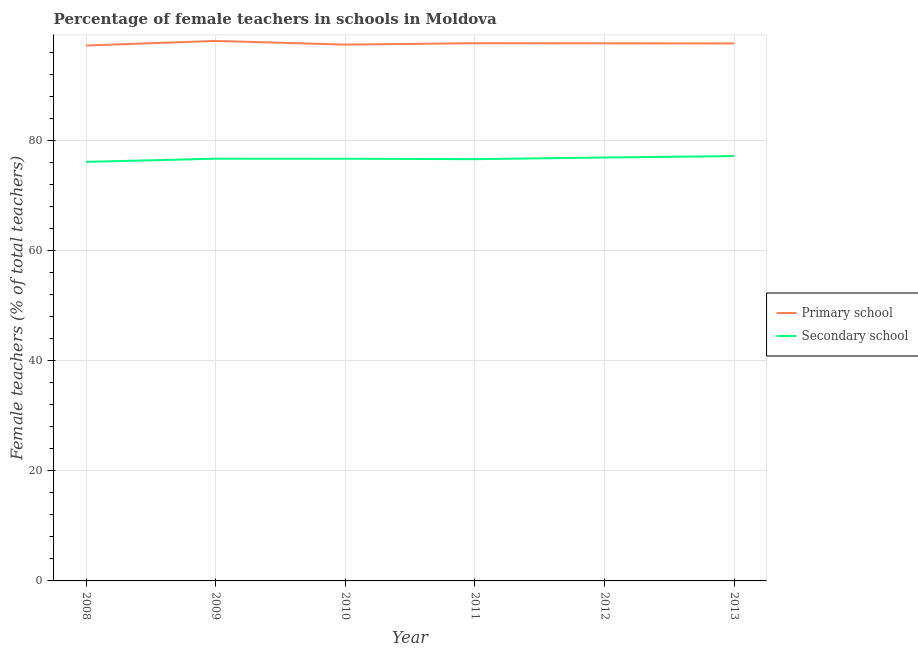How many different coloured lines are there?
Offer a very short reply. 2. Is the number of lines equal to the number of legend labels?
Ensure brevity in your answer.  Yes. What is the percentage of female teachers in secondary schools in 2012?
Give a very brief answer. 76.97. Across all years, what is the maximum percentage of female teachers in primary schools?
Keep it short and to the point. 98.16. Across all years, what is the minimum percentage of female teachers in primary schools?
Your answer should be very brief. 97.32. In which year was the percentage of female teachers in primary schools maximum?
Provide a succinct answer. 2009. In which year was the percentage of female teachers in secondary schools minimum?
Keep it short and to the point. 2008. What is the total percentage of female teachers in primary schools in the graph?
Offer a terse response. 586.14. What is the difference between the percentage of female teachers in secondary schools in 2009 and that in 2010?
Provide a short and direct response. 0.01. What is the difference between the percentage of female teachers in secondary schools in 2013 and the percentage of female teachers in primary schools in 2011?
Your answer should be compact. -20.52. What is the average percentage of female teachers in secondary schools per year?
Give a very brief answer. 76.75. In the year 2009, what is the difference between the percentage of female teachers in primary schools and percentage of female teachers in secondary schools?
Your answer should be compact. 21.41. In how many years, is the percentage of female teachers in primary schools greater than 68 %?
Give a very brief answer. 6. What is the ratio of the percentage of female teachers in secondary schools in 2010 to that in 2012?
Ensure brevity in your answer.  1. Is the percentage of female teachers in secondary schools in 2010 less than that in 2012?
Provide a short and direct response. Yes. Is the difference between the percentage of female teachers in primary schools in 2010 and 2011 greater than the difference between the percentage of female teachers in secondary schools in 2010 and 2011?
Offer a terse response. No. What is the difference between the highest and the second highest percentage of female teachers in primary schools?
Your answer should be very brief. 0.42. What is the difference between the highest and the lowest percentage of female teachers in secondary schools?
Provide a succinct answer. 1.06. In how many years, is the percentage of female teachers in primary schools greater than the average percentage of female teachers in primary schools taken over all years?
Provide a short and direct response. 4. Is the percentage of female teachers in secondary schools strictly less than the percentage of female teachers in primary schools over the years?
Your answer should be compact. Yes. How many lines are there?
Ensure brevity in your answer.  2. What is the difference between two consecutive major ticks on the Y-axis?
Provide a short and direct response. 20. Does the graph contain any zero values?
Keep it short and to the point. No. Does the graph contain grids?
Your answer should be compact. Yes. How are the legend labels stacked?
Offer a very short reply. Vertical. What is the title of the graph?
Your answer should be compact. Percentage of female teachers in schools in Moldova. What is the label or title of the Y-axis?
Ensure brevity in your answer.  Female teachers (% of total teachers). What is the Female teachers (% of total teachers) of Primary school in 2008?
Offer a very short reply. 97.32. What is the Female teachers (% of total teachers) of Secondary school in 2008?
Keep it short and to the point. 76.17. What is the Female teachers (% of total teachers) in Primary school in 2009?
Ensure brevity in your answer.  98.16. What is the Female teachers (% of total teachers) of Secondary school in 2009?
Your answer should be compact. 76.75. What is the Female teachers (% of total teachers) of Primary school in 2010?
Offer a terse response. 97.49. What is the Female teachers (% of total teachers) in Secondary school in 2010?
Your answer should be very brief. 76.74. What is the Female teachers (% of total teachers) in Primary school in 2011?
Your answer should be compact. 97.74. What is the Female teachers (% of total teachers) in Secondary school in 2011?
Your response must be concise. 76.66. What is the Female teachers (% of total teachers) in Primary school in 2012?
Provide a short and direct response. 97.72. What is the Female teachers (% of total teachers) in Secondary school in 2012?
Give a very brief answer. 76.97. What is the Female teachers (% of total teachers) of Primary school in 2013?
Ensure brevity in your answer.  97.7. What is the Female teachers (% of total teachers) of Secondary school in 2013?
Your response must be concise. 77.23. Across all years, what is the maximum Female teachers (% of total teachers) of Primary school?
Ensure brevity in your answer.  98.16. Across all years, what is the maximum Female teachers (% of total teachers) in Secondary school?
Your answer should be very brief. 77.23. Across all years, what is the minimum Female teachers (% of total teachers) in Primary school?
Provide a short and direct response. 97.32. Across all years, what is the minimum Female teachers (% of total teachers) in Secondary school?
Ensure brevity in your answer.  76.17. What is the total Female teachers (% of total teachers) in Primary school in the graph?
Your answer should be very brief. 586.14. What is the total Female teachers (% of total teachers) in Secondary school in the graph?
Keep it short and to the point. 460.52. What is the difference between the Female teachers (% of total teachers) in Primary school in 2008 and that in 2009?
Your answer should be very brief. -0.83. What is the difference between the Female teachers (% of total teachers) in Secondary school in 2008 and that in 2009?
Your answer should be compact. -0.58. What is the difference between the Female teachers (% of total teachers) of Primary school in 2008 and that in 2010?
Provide a short and direct response. -0.17. What is the difference between the Female teachers (% of total teachers) of Secondary school in 2008 and that in 2010?
Ensure brevity in your answer.  -0.57. What is the difference between the Female teachers (% of total teachers) in Primary school in 2008 and that in 2011?
Make the answer very short. -0.42. What is the difference between the Female teachers (% of total teachers) of Secondary school in 2008 and that in 2011?
Your response must be concise. -0.49. What is the difference between the Female teachers (% of total teachers) of Primary school in 2008 and that in 2012?
Offer a terse response. -0.4. What is the difference between the Female teachers (% of total teachers) of Secondary school in 2008 and that in 2012?
Provide a succinct answer. -0.8. What is the difference between the Female teachers (% of total teachers) in Primary school in 2008 and that in 2013?
Your response must be concise. -0.37. What is the difference between the Female teachers (% of total teachers) of Secondary school in 2008 and that in 2013?
Keep it short and to the point. -1.06. What is the difference between the Female teachers (% of total teachers) of Primary school in 2009 and that in 2010?
Your answer should be very brief. 0.67. What is the difference between the Female teachers (% of total teachers) in Secondary school in 2009 and that in 2010?
Offer a very short reply. 0.01. What is the difference between the Female teachers (% of total teachers) of Primary school in 2009 and that in 2011?
Offer a terse response. 0.42. What is the difference between the Female teachers (% of total teachers) of Secondary school in 2009 and that in 2011?
Make the answer very short. 0.09. What is the difference between the Female teachers (% of total teachers) of Primary school in 2009 and that in 2012?
Your response must be concise. 0.43. What is the difference between the Female teachers (% of total teachers) in Secondary school in 2009 and that in 2012?
Provide a short and direct response. -0.22. What is the difference between the Female teachers (% of total teachers) in Primary school in 2009 and that in 2013?
Give a very brief answer. 0.46. What is the difference between the Female teachers (% of total teachers) of Secondary school in 2009 and that in 2013?
Offer a very short reply. -0.47. What is the difference between the Female teachers (% of total teachers) in Primary school in 2010 and that in 2011?
Offer a very short reply. -0.25. What is the difference between the Female teachers (% of total teachers) in Secondary school in 2010 and that in 2011?
Ensure brevity in your answer.  0.08. What is the difference between the Female teachers (% of total teachers) of Primary school in 2010 and that in 2012?
Keep it short and to the point. -0.24. What is the difference between the Female teachers (% of total teachers) of Secondary school in 2010 and that in 2012?
Provide a short and direct response. -0.23. What is the difference between the Female teachers (% of total teachers) of Primary school in 2010 and that in 2013?
Provide a succinct answer. -0.21. What is the difference between the Female teachers (% of total teachers) of Secondary school in 2010 and that in 2013?
Give a very brief answer. -0.48. What is the difference between the Female teachers (% of total teachers) in Primary school in 2011 and that in 2012?
Give a very brief answer. 0.02. What is the difference between the Female teachers (% of total teachers) in Secondary school in 2011 and that in 2012?
Offer a very short reply. -0.31. What is the difference between the Female teachers (% of total teachers) of Primary school in 2011 and that in 2013?
Keep it short and to the point. 0.05. What is the difference between the Female teachers (% of total teachers) of Secondary school in 2011 and that in 2013?
Offer a terse response. -0.56. What is the difference between the Female teachers (% of total teachers) in Primary school in 2012 and that in 2013?
Offer a very short reply. 0.03. What is the difference between the Female teachers (% of total teachers) of Secondary school in 2012 and that in 2013?
Ensure brevity in your answer.  -0.26. What is the difference between the Female teachers (% of total teachers) in Primary school in 2008 and the Female teachers (% of total teachers) in Secondary school in 2009?
Keep it short and to the point. 20.57. What is the difference between the Female teachers (% of total teachers) in Primary school in 2008 and the Female teachers (% of total teachers) in Secondary school in 2010?
Give a very brief answer. 20.58. What is the difference between the Female teachers (% of total teachers) of Primary school in 2008 and the Female teachers (% of total teachers) of Secondary school in 2011?
Make the answer very short. 20.66. What is the difference between the Female teachers (% of total teachers) in Primary school in 2008 and the Female teachers (% of total teachers) in Secondary school in 2012?
Keep it short and to the point. 20.35. What is the difference between the Female teachers (% of total teachers) of Primary school in 2008 and the Female teachers (% of total teachers) of Secondary school in 2013?
Ensure brevity in your answer.  20.1. What is the difference between the Female teachers (% of total teachers) in Primary school in 2009 and the Female teachers (% of total teachers) in Secondary school in 2010?
Your answer should be very brief. 21.42. What is the difference between the Female teachers (% of total teachers) of Primary school in 2009 and the Female teachers (% of total teachers) of Secondary school in 2011?
Offer a terse response. 21.5. What is the difference between the Female teachers (% of total teachers) in Primary school in 2009 and the Female teachers (% of total teachers) in Secondary school in 2012?
Make the answer very short. 21.19. What is the difference between the Female teachers (% of total teachers) of Primary school in 2009 and the Female teachers (% of total teachers) of Secondary school in 2013?
Offer a terse response. 20.93. What is the difference between the Female teachers (% of total teachers) of Primary school in 2010 and the Female teachers (% of total teachers) of Secondary school in 2011?
Keep it short and to the point. 20.83. What is the difference between the Female teachers (% of total teachers) in Primary school in 2010 and the Female teachers (% of total teachers) in Secondary school in 2012?
Your response must be concise. 20.52. What is the difference between the Female teachers (% of total teachers) of Primary school in 2010 and the Female teachers (% of total teachers) of Secondary school in 2013?
Give a very brief answer. 20.26. What is the difference between the Female teachers (% of total teachers) of Primary school in 2011 and the Female teachers (% of total teachers) of Secondary school in 2012?
Your answer should be compact. 20.77. What is the difference between the Female teachers (% of total teachers) of Primary school in 2011 and the Female teachers (% of total teachers) of Secondary school in 2013?
Your response must be concise. 20.52. What is the difference between the Female teachers (% of total teachers) of Primary school in 2012 and the Female teachers (% of total teachers) of Secondary school in 2013?
Provide a succinct answer. 20.5. What is the average Female teachers (% of total teachers) of Primary school per year?
Give a very brief answer. 97.69. What is the average Female teachers (% of total teachers) in Secondary school per year?
Provide a short and direct response. 76.75. In the year 2008, what is the difference between the Female teachers (% of total teachers) of Primary school and Female teachers (% of total teachers) of Secondary school?
Give a very brief answer. 21.16. In the year 2009, what is the difference between the Female teachers (% of total teachers) in Primary school and Female teachers (% of total teachers) in Secondary school?
Provide a succinct answer. 21.41. In the year 2010, what is the difference between the Female teachers (% of total teachers) in Primary school and Female teachers (% of total teachers) in Secondary school?
Provide a short and direct response. 20.75. In the year 2011, what is the difference between the Female teachers (% of total teachers) in Primary school and Female teachers (% of total teachers) in Secondary school?
Your answer should be very brief. 21.08. In the year 2012, what is the difference between the Female teachers (% of total teachers) in Primary school and Female teachers (% of total teachers) in Secondary school?
Keep it short and to the point. 20.76. In the year 2013, what is the difference between the Female teachers (% of total teachers) in Primary school and Female teachers (% of total teachers) in Secondary school?
Your answer should be very brief. 20.47. What is the ratio of the Female teachers (% of total teachers) in Secondary school in 2008 to that in 2009?
Give a very brief answer. 0.99. What is the ratio of the Female teachers (% of total teachers) of Secondary school in 2008 to that in 2010?
Provide a short and direct response. 0.99. What is the ratio of the Female teachers (% of total teachers) of Primary school in 2008 to that in 2011?
Your answer should be very brief. 1. What is the ratio of the Female teachers (% of total teachers) of Primary school in 2008 to that in 2012?
Your response must be concise. 1. What is the ratio of the Female teachers (% of total teachers) in Secondary school in 2008 to that in 2012?
Provide a short and direct response. 0.99. What is the ratio of the Female teachers (% of total teachers) in Secondary school in 2008 to that in 2013?
Provide a succinct answer. 0.99. What is the ratio of the Female teachers (% of total teachers) of Secondary school in 2009 to that in 2010?
Your answer should be compact. 1. What is the ratio of the Female teachers (% of total teachers) of Primary school in 2009 to that in 2011?
Give a very brief answer. 1. What is the ratio of the Female teachers (% of total teachers) of Secondary school in 2009 to that in 2012?
Give a very brief answer. 1. What is the ratio of the Female teachers (% of total teachers) in Primary school in 2010 to that in 2011?
Offer a terse response. 1. What is the ratio of the Female teachers (% of total teachers) in Secondary school in 2011 to that in 2012?
Keep it short and to the point. 1. What is the ratio of the Female teachers (% of total teachers) of Primary school in 2011 to that in 2013?
Make the answer very short. 1. What is the ratio of the Female teachers (% of total teachers) of Secondary school in 2011 to that in 2013?
Your answer should be compact. 0.99. What is the ratio of the Female teachers (% of total teachers) of Primary school in 2012 to that in 2013?
Your answer should be compact. 1. What is the difference between the highest and the second highest Female teachers (% of total teachers) in Primary school?
Your answer should be very brief. 0.42. What is the difference between the highest and the second highest Female teachers (% of total teachers) in Secondary school?
Keep it short and to the point. 0.26. What is the difference between the highest and the lowest Female teachers (% of total teachers) in Primary school?
Keep it short and to the point. 0.83. What is the difference between the highest and the lowest Female teachers (% of total teachers) in Secondary school?
Make the answer very short. 1.06. 